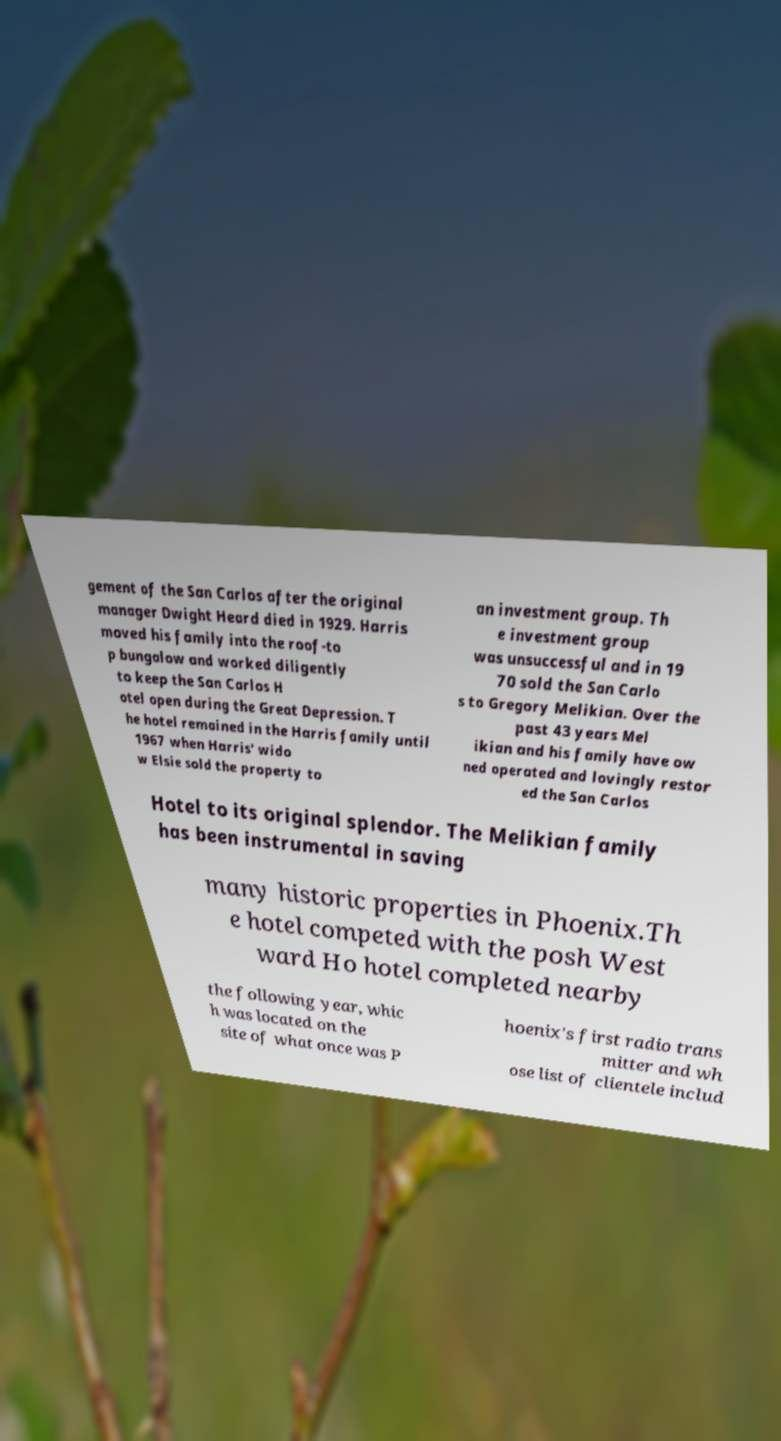There's text embedded in this image that I need extracted. Can you transcribe it verbatim? gement of the San Carlos after the original manager Dwight Heard died in 1929. Harris moved his family into the roof-to p bungalow and worked diligently to keep the San Carlos H otel open during the Great Depression. T he hotel remained in the Harris family until 1967 when Harris' wido w Elsie sold the property to an investment group. Th e investment group was unsuccessful and in 19 70 sold the San Carlo s to Gregory Melikian. Over the past 43 years Mel ikian and his family have ow ned operated and lovingly restor ed the San Carlos Hotel to its original splendor. The Melikian family has been instrumental in saving many historic properties in Phoenix.Th e hotel competed with the posh West ward Ho hotel completed nearby the following year, whic h was located on the site of what once was P hoenix's first radio trans mitter and wh ose list of clientele includ 